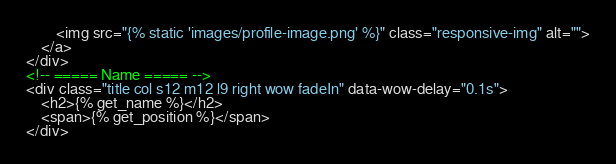<code> <loc_0><loc_0><loc_500><loc_500><_HTML_>        <img src="{% static 'images/profile-image.png' %}" class="responsive-img" alt="">
    </a>
</div>
<!-- ===== Name ===== -->
<div class="title col s12 m12 l9 right wow fadeIn" data-wow-delay="0.1s">
    <h2>{% get_name %}</h2>
    <span>{% get_position %}</span>
</div></code> 